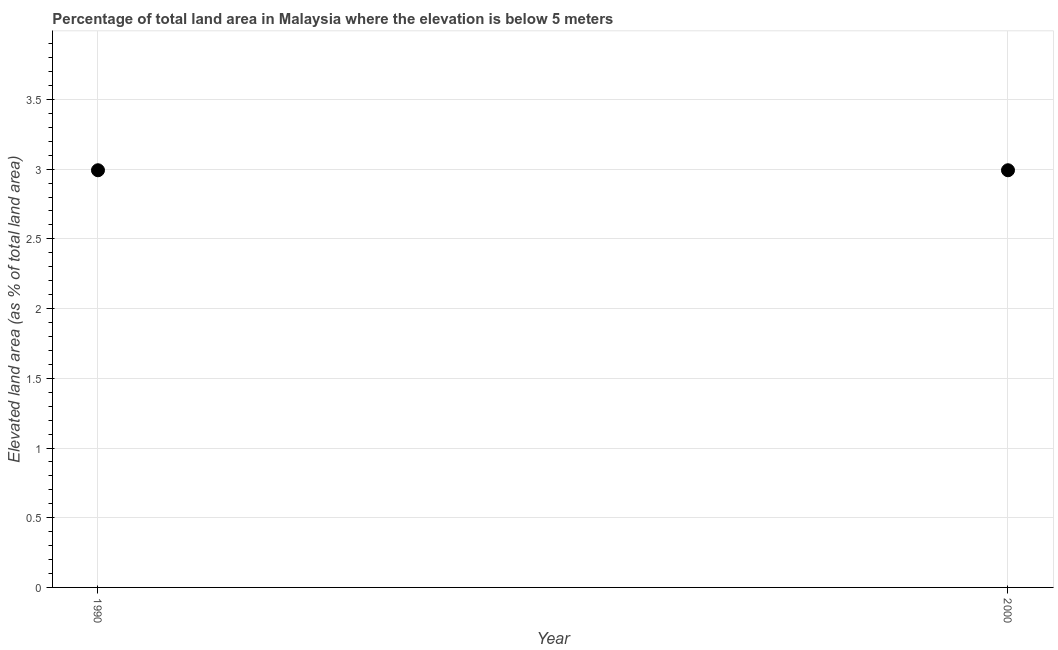What is the total elevated land area in 1990?
Your response must be concise. 2.99. Across all years, what is the maximum total elevated land area?
Your answer should be very brief. 2.99. Across all years, what is the minimum total elevated land area?
Offer a terse response. 2.99. In which year was the total elevated land area maximum?
Your response must be concise. 1990. In which year was the total elevated land area minimum?
Your response must be concise. 1990. What is the sum of the total elevated land area?
Your answer should be very brief. 5.98. What is the average total elevated land area per year?
Keep it short and to the point. 2.99. What is the median total elevated land area?
Keep it short and to the point. 2.99. Do a majority of the years between 2000 and 1990 (inclusive) have total elevated land area greater than 1.3 %?
Your answer should be very brief. No. What is the ratio of the total elevated land area in 1990 to that in 2000?
Your answer should be compact. 1. Is the total elevated land area in 1990 less than that in 2000?
Offer a terse response. No. In how many years, is the total elevated land area greater than the average total elevated land area taken over all years?
Ensure brevity in your answer.  0. Does the total elevated land area monotonically increase over the years?
Offer a very short reply. No. How many dotlines are there?
Offer a very short reply. 1. How many years are there in the graph?
Make the answer very short. 2. Does the graph contain grids?
Your response must be concise. Yes. What is the title of the graph?
Keep it short and to the point. Percentage of total land area in Malaysia where the elevation is below 5 meters. What is the label or title of the X-axis?
Your answer should be very brief. Year. What is the label or title of the Y-axis?
Keep it short and to the point. Elevated land area (as % of total land area). What is the Elevated land area (as % of total land area) in 1990?
Keep it short and to the point. 2.99. What is the Elevated land area (as % of total land area) in 2000?
Your answer should be compact. 2.99. What is the difference between the Elevated land area (as % of total land area) in 1990 and 2000?
Provide a short and direct response. 0. 